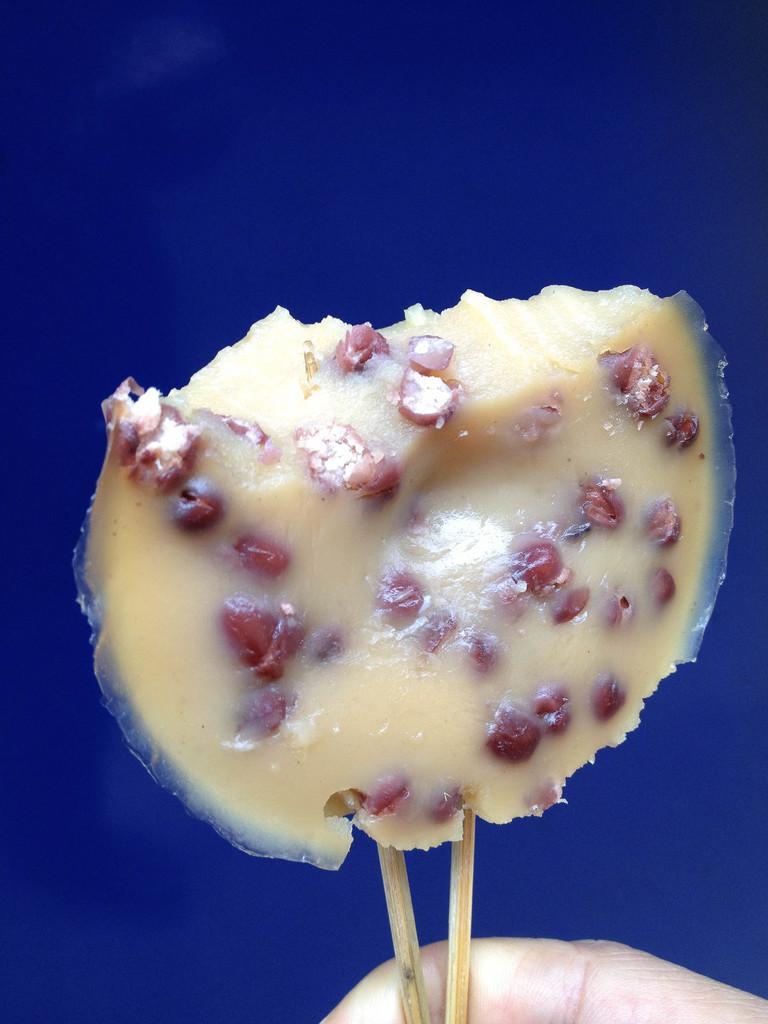Describe this image in one or two sentences. In this image we can see a food item with sticks. At the bottom we can see a finger of a person. The background of the image is blue. 